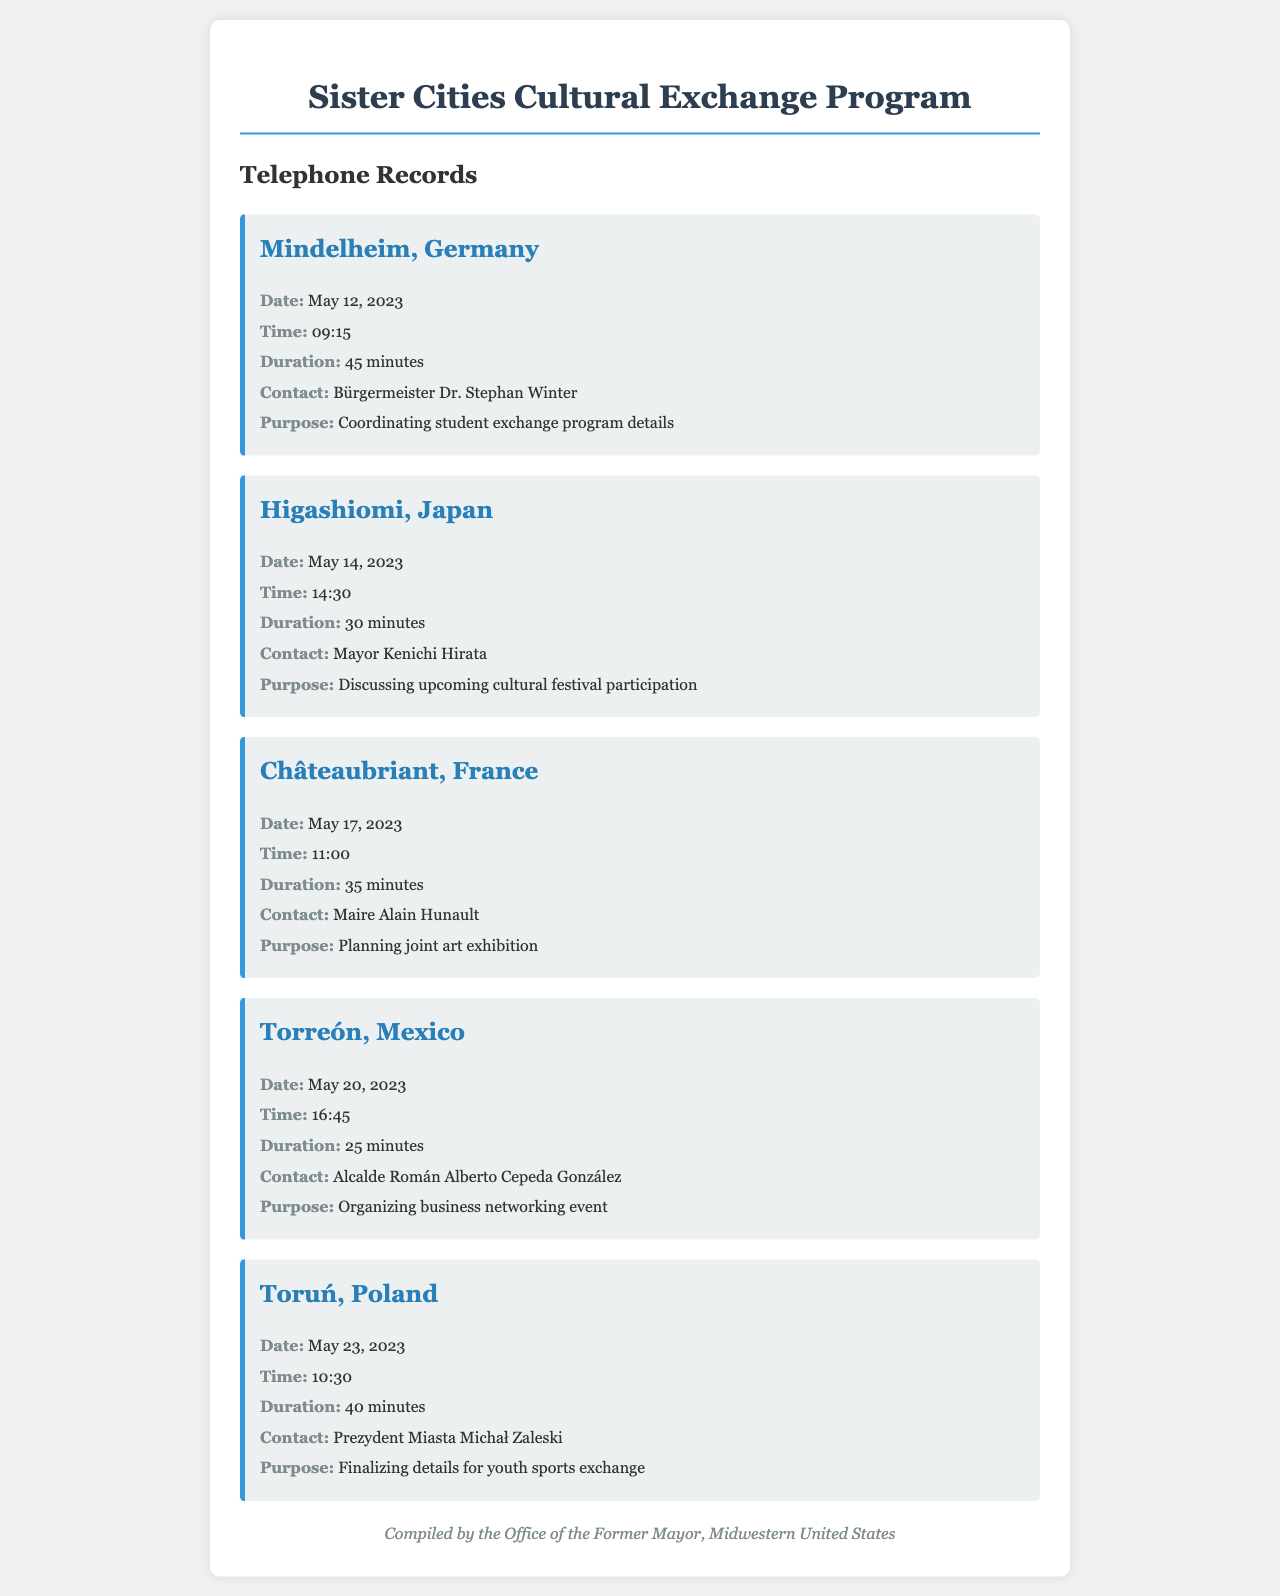What is the date of the call to Mindelheim, Germany? The date of the call is mentioned specifically in the document under the record for Mindelheim, which is May 12, 2023.
Answer: May 12, 2023 Who is the contact for the call to Higashiomi, Japan? The contact is listed in the record for Higashiomi, which is Mayor Kenichi Hirata.
Answer: Mayor Kenichi Hirata What was the duration of the call to Châteaubriant, France? The duration is provided in the record for Châteaubriant, which states it was 35 minutes.
Answer: 35 minutes What was the purpose of the call to Torreón, Mexico? The purpose is detailed in the Torreón record, which indicates it was for organizing a business networking event.
Answer: Organizing business networking event How many minutes did the call to Toruń, Poland last? The document specifies the duration of the call to Toruń, which is 40 minutes.
Answer: 40 minutes Which city was called on May 14, 2023? The specific date is linked to the call to Higashiomi, which occurred on that date.
Answer: Higashiomi Which country's mayor was contacted to discuss a cultural festival? The document mentions Higashiomi as the city involved in discussing the cultural festival participation.
Answer: Japan What is the title of the contact for Mindelheim, Germany? The title is provided in the record for Mindelheim, which states Bürgermeister Dr. Stephan Winter.
Answer: Bürgermeister Dr. Stephan Winter 